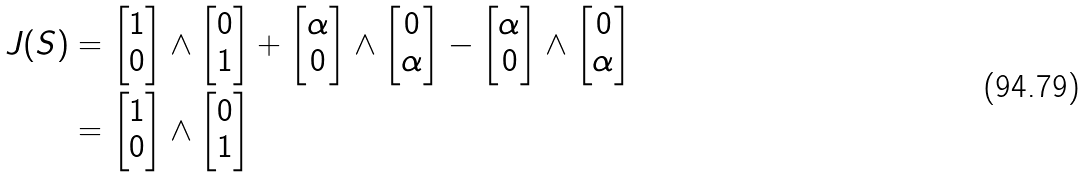<formula> <loc_0><loc_0><loc_500><loc_500>J ( S ) & = \begin{bmatrix} 1 \\ 0 \end{bmatrix} \wedge \begin{bmatrix} 0 \\ 1 \end{bmatrix} + \begin{bmatrix} \alpha \\ 0 \end{bmatrix} \wedge \begin{bmatrix} 0 \\ \alpha \end{bmatrix} - \begin{bmatrix} \alpha \\ 0 \end{bmatrix} \wedge \begin{bmatrix} 0 \\ \alpha \end{bmatrix} \\ & = \begin{bmatrix} 1 \\ 0 \end{bmatrix} \wedge \begin{bmatrix} 0 \\ 1 \end{bmatrix}</formula> 